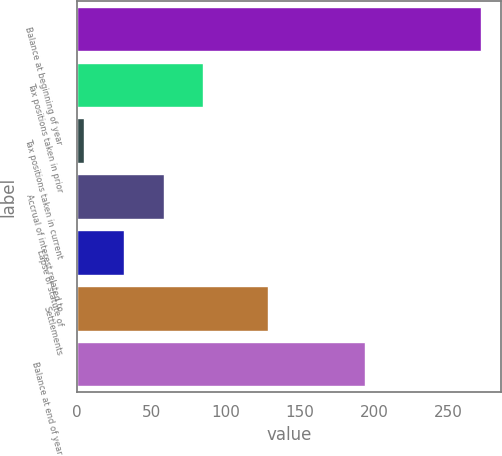<chart> <loc_0><loc_0><loc_500><loc_500><bar_chart><fcel>Balance at beginning of year<fcel>Tax positions taken in prior<fcel>Tax positions taken in current<fcel>Accrual of interest related to<fcel>Lapse of statute of<fcel>Settlements<fcel>Balance at end of year<nl><fcel>272<fcel>85.1<fcel>5<fcel>58.4<fcel>31.7<fcel>129<fcel>194<nl></chart> 